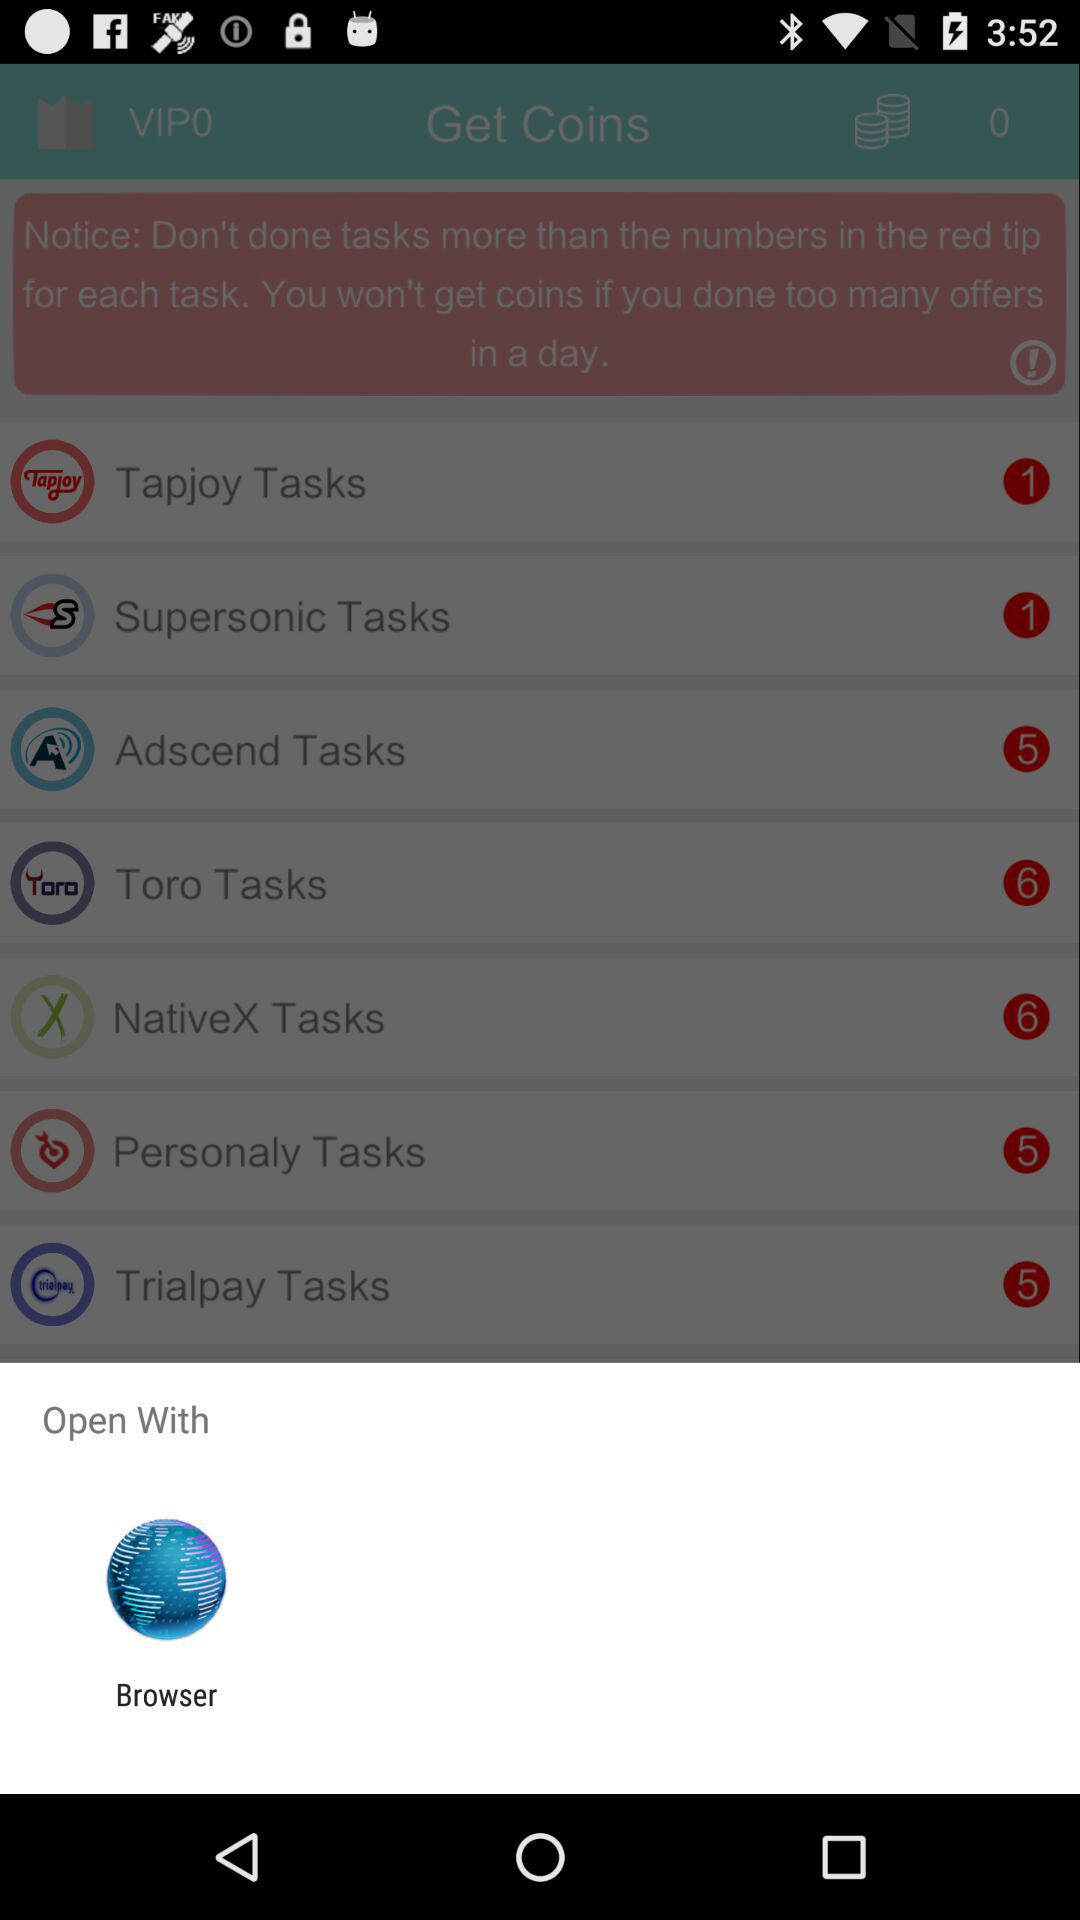What application should I choose to open? You should choose to open with "Browser". 